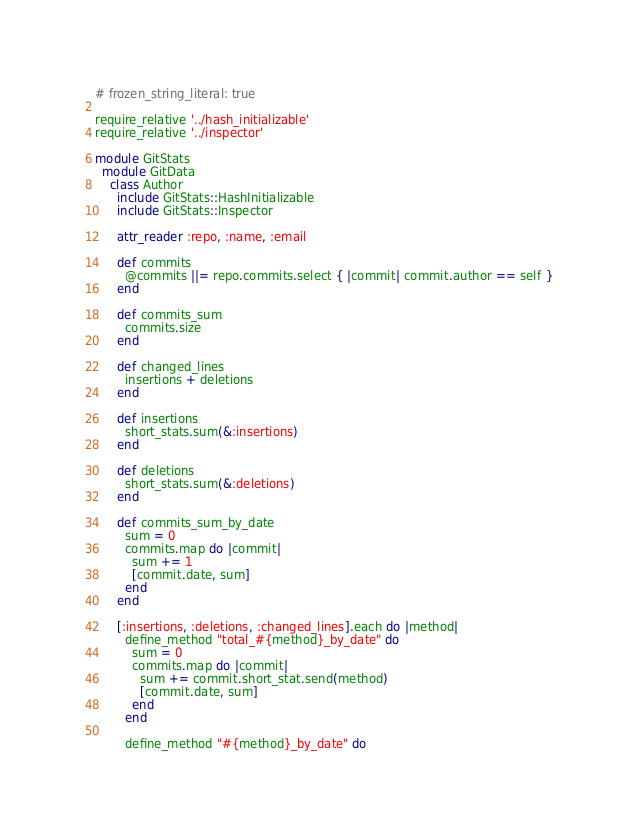Convert code to text. <code><loc_0><loc_0><loc_500><loc_500><_Ruby_># frozen_string_literal: true

require_relative '../hash_initializable'
require_relative '../inspector'

module GitStats
  module GitData
    class Author
      include GitStats::HashInitializable
      include GitStats::Inspector

      attr_reader :repo, :name, :email

      def commits
        @commits ||= repo.commits.select { |commit| commit.author == self }
      end

      def commits_sum
        commits.size
      end

      def changed_lines
        insertions + deletions
      end

      def insertions
        short_stats.sum(&:insertions)
      end

      def deletions
        short_stats.sum(&:deletions)
      end

      def commits_sum_by_date
        sum = 0
        commits.map do |commit|
          sum += 1
          [commit.date, sum]
        end
      end

      [:insertions, :deletions, :changed_lines].each do |method|
        define_method "total_#{method}_by_date" do
          sum = 0
          commits.map do |commit|
            sum += commit.short_stat.send(method)
            [commit.date, sum]
          end
        end

        define_method "#{method}_by_date" do</code> 